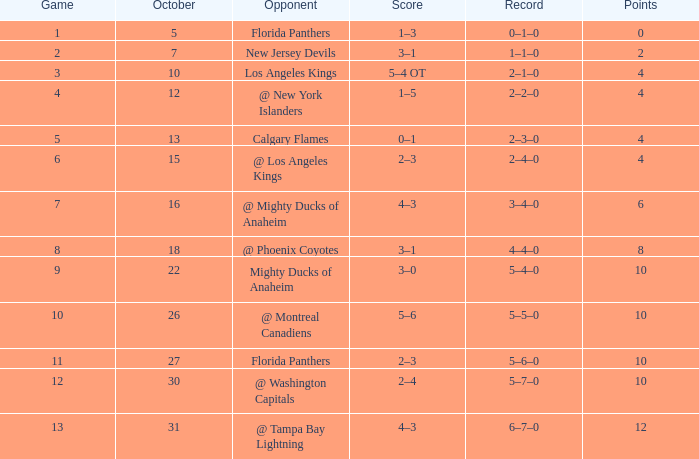What team has a score of 11 5–6–0. 